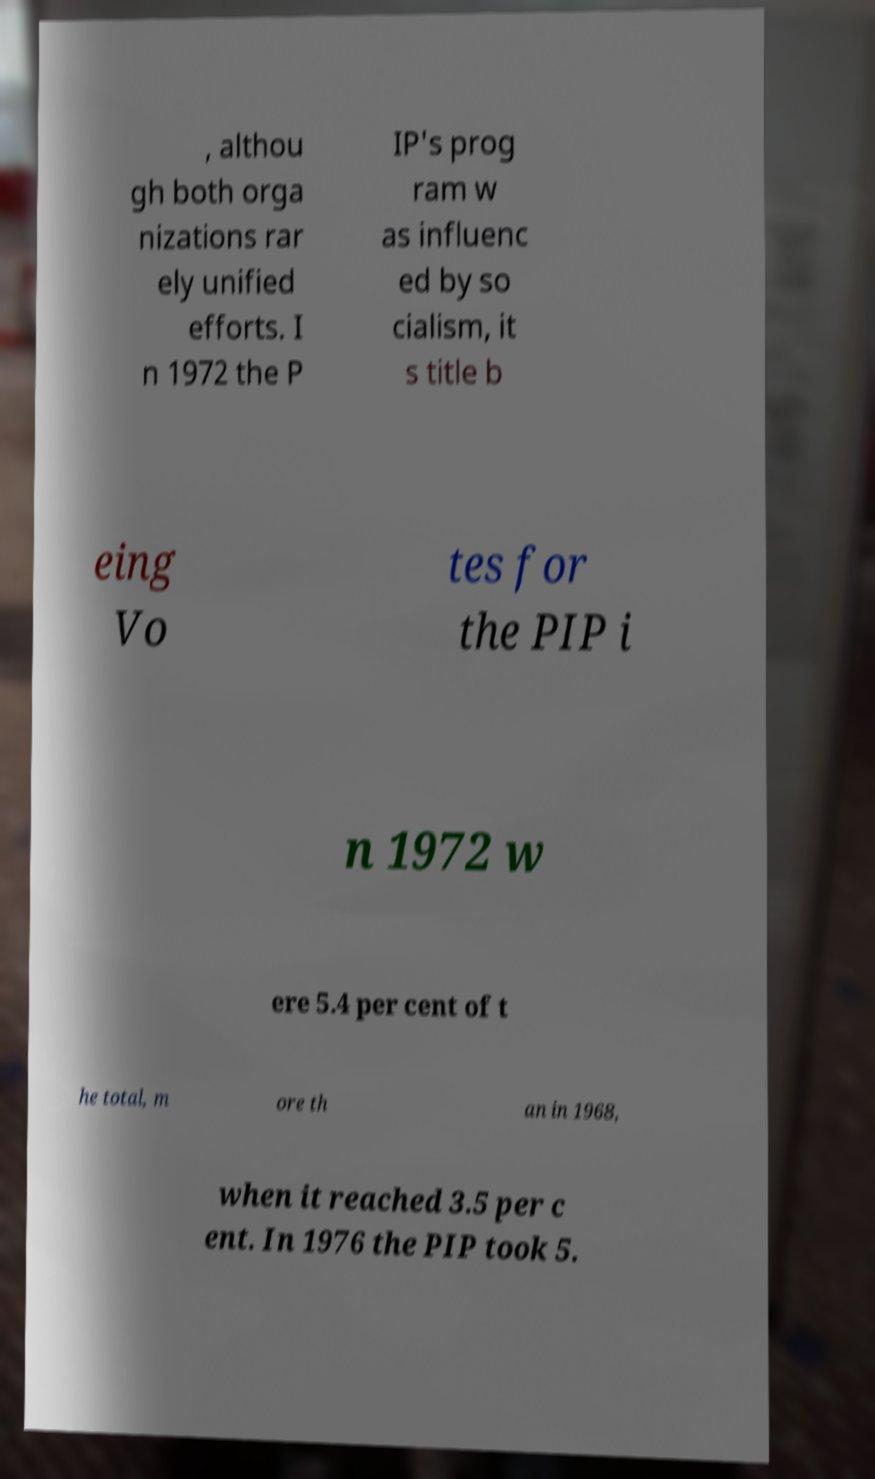There's text embedded in this image that I need extracted. Can you transcribe it verbatim? , althou gh both orga nizations rar ely unified efforts. I n 1972 the P IP's prog ram w as influenc ed by so cialism, it s title b eing Vo tes for the PIP i n 1972 w ere 5.4 per cent of t he total, m ore th an in 1968, when it reached 3.5 per c ent. In 1976 the PIP took 5. 